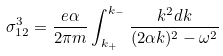Convert formula to latex. <formula><loc_0><loc_0><loc_500><loc_500>\sigma ^ { 3 } _ { 1 2 } = \frac { e \alpha } { 2 \pi m } \int _ { k _ { + } } ^ { k _ { - } } \frac { k ^ { 2 } d k } { ( 2 \alpha k ) ^ { 2 } - \omega ^ { 2 } }</formula> 